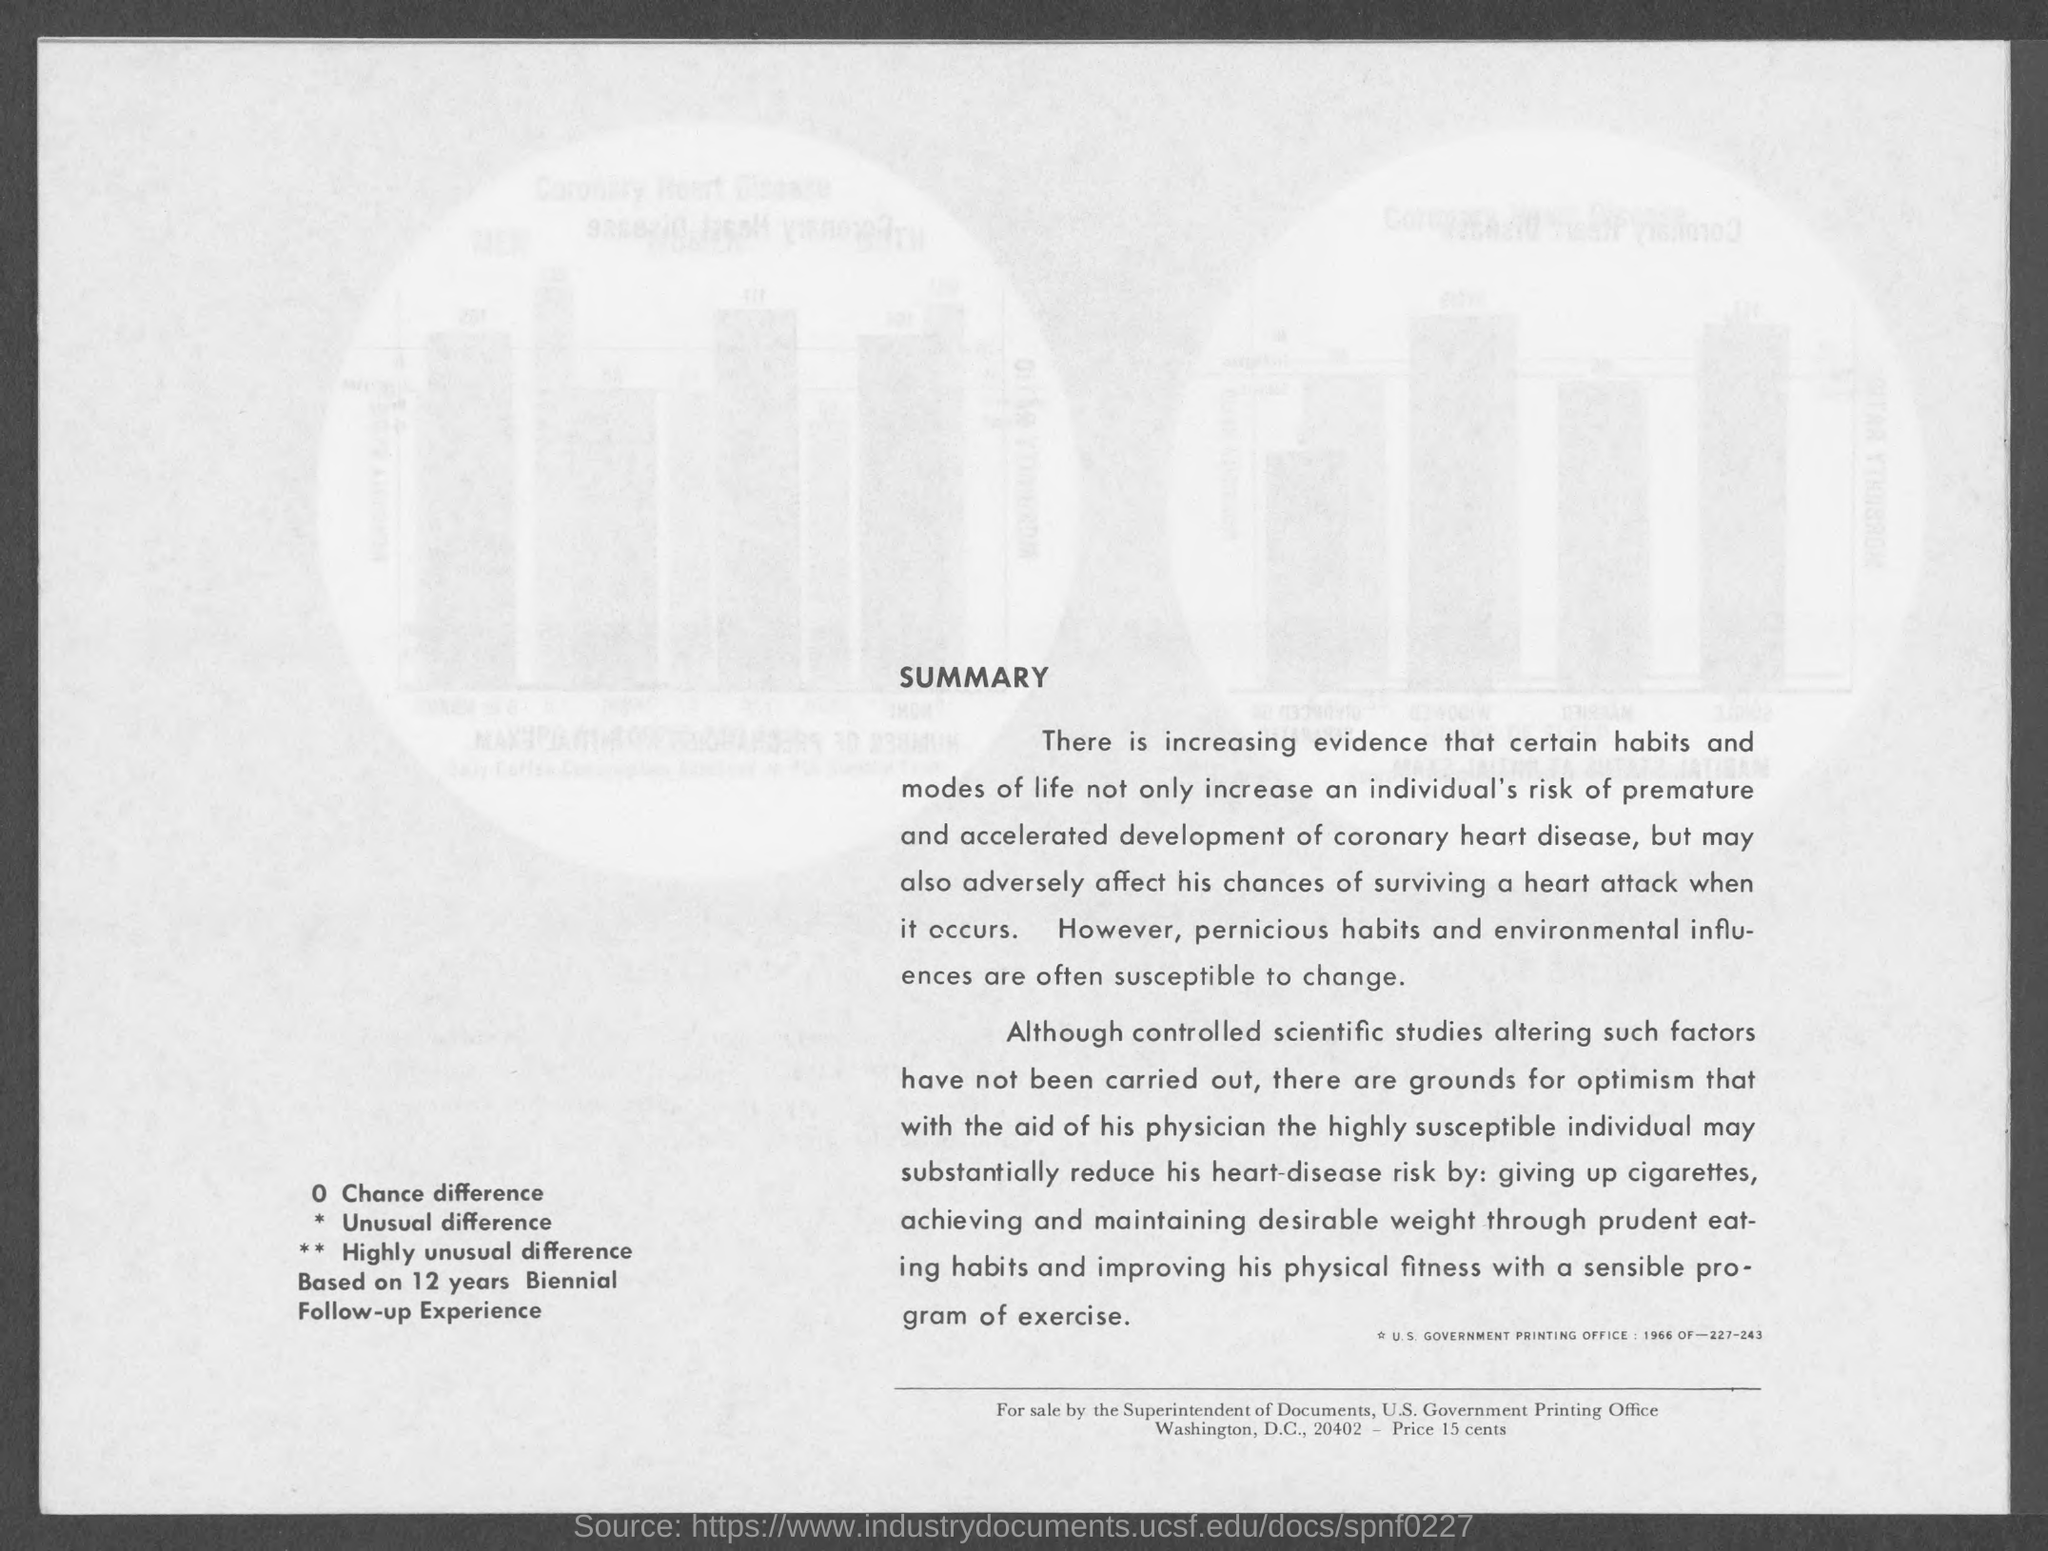Highlight a few significant elements in this photo. The document is being sold by the Superintendent of Documents. The price is 15 cents. 